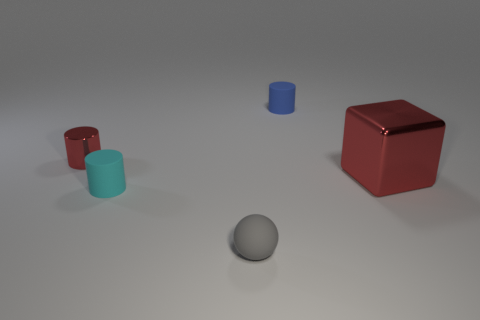Add 1 small red shiny objects. How many objects exist? 6 Subtract all cylinders. How many objects are left? 2 Subtract 0 yellow spheres. How many objects are left? 5 Subtract all big purple rubber things. Subtract all tiny cyan matte cylinders. How many objects are left? 4 Add 2 big metallic objects. How many big metallic objects are left? 3 Add 5 matte balls. How many matte balls exist? 6 